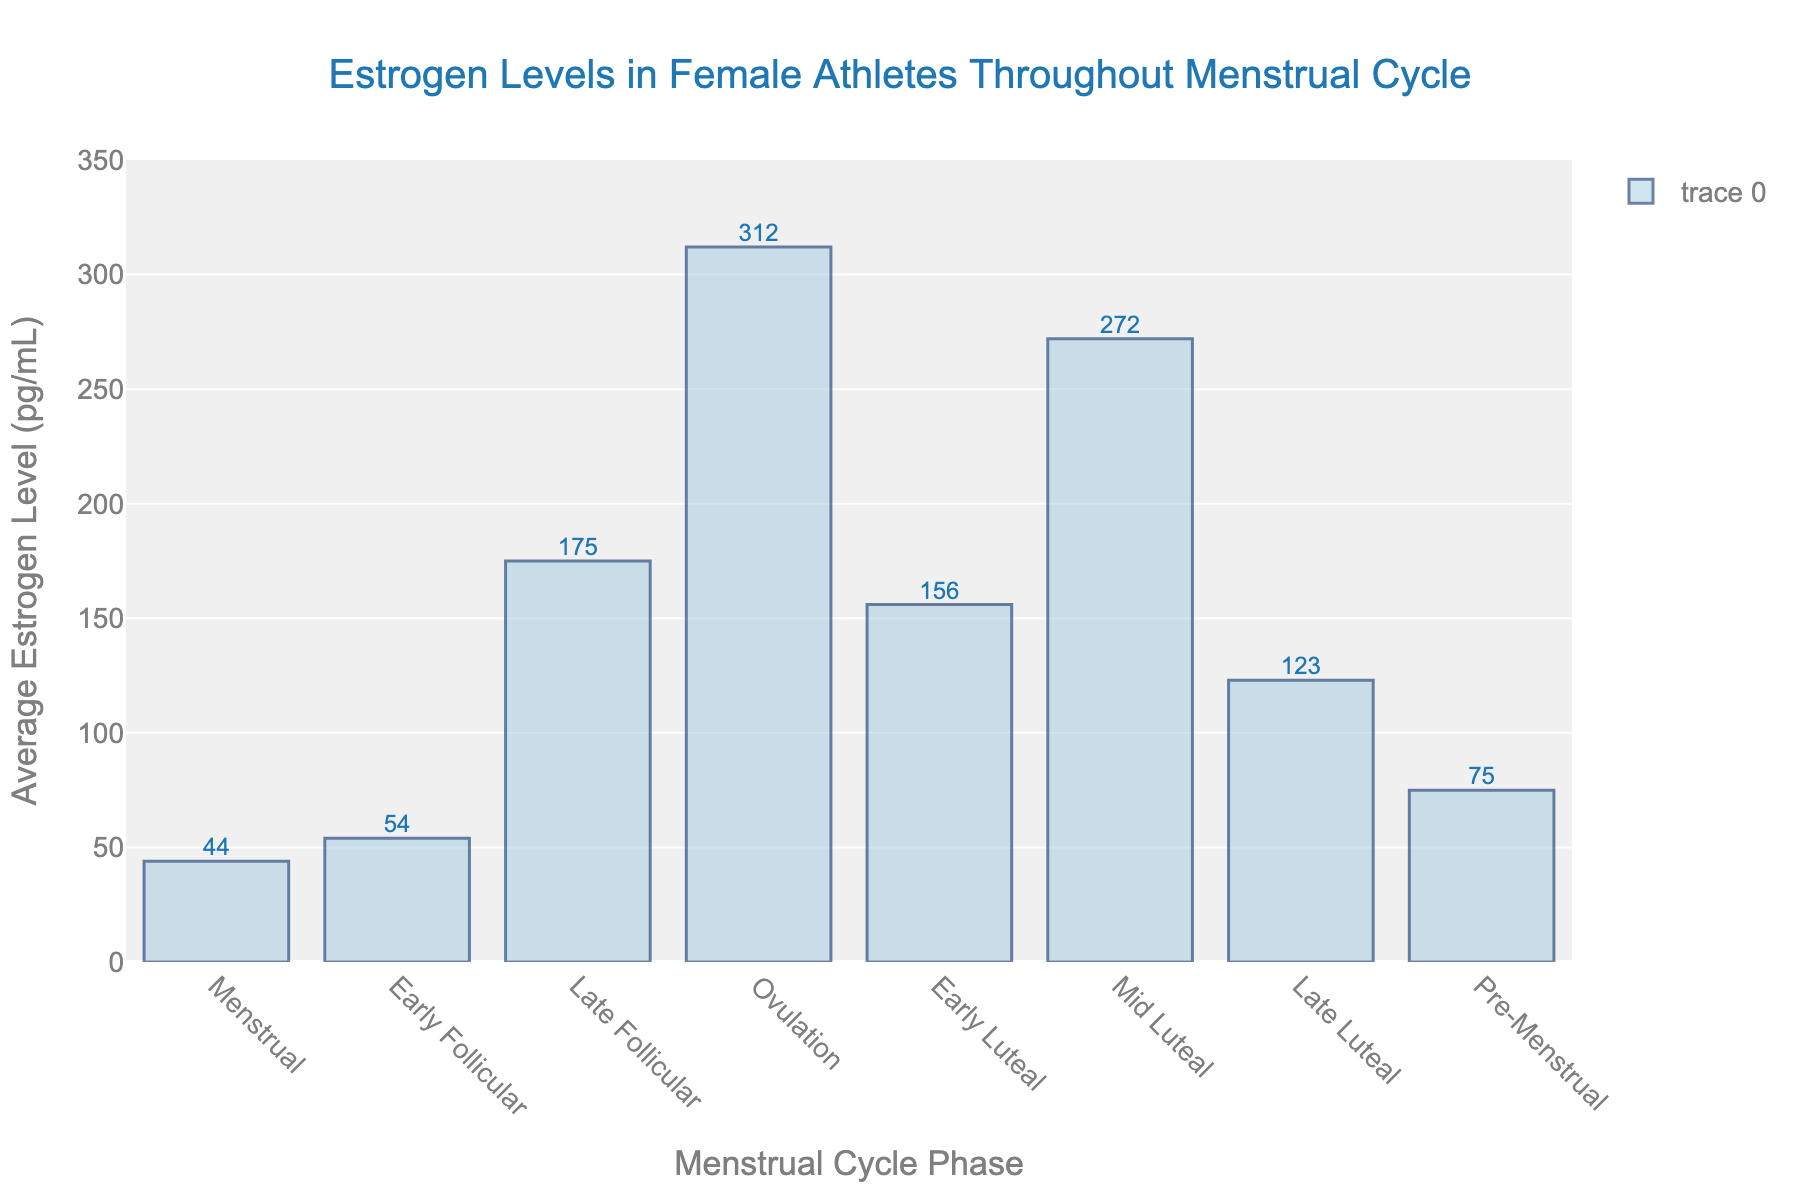Which phase has the highest average estrogen level? Identify the tallest bar in the chart, which represents the highest estrogen level. The bar for the Ovulation phase is the tallest.
Answer: Ovulation What is the difference in average estrogen levels between the Ovulation and Menstrual phases? Locate the estrogen levels of the Ovulation and Menstrual phases (312 pg/mL and 44 pg/mL, respectively). Subtract the Menstrual level from the Ovulation level: 312 - 44 = 268 pg/mL.
Answer: 268 pg/mL During which phase does the estrogen level first exceed 100 pg/mL? Examine each phase's estrogen level in ascending order. The Late Follicular phase shows an estrogen level of 175 pg/mL, which is the first value exceeding 100 pg/mL.
Answer: Late Follicular By how much does the estrogen level drop from its peak at Ovulation to the Early Luteal phase? Find the levels at Ovulation and Early Luteal phases (312 pg/mL and 156 pg/mL, respectively). Calculate the drop: 312 - 156 = 156 pg/mL.
Answer: 156 pg/mL What is the total average estrogen level across all phases? Sum the estrogen levels of all phases (44 + 54 + 175 + 312 + 156 + 272 + 123 + 75) = 1211 pg/mL.
Answer: 1211 pg/mL Which phase has the closest estrogen level to the average of the Menstrual and Pre-Menstrual phases? Calculate the average of the Menstrual and Pre-Menstrual phases: (44 + 75) / 2 = 59.5 pg/mL. Determine which phase's estrogen level is closest to 59.5 pg/mL (Early Follicular at 54 pg/mL).
Answer: Early Follicular How does the estrogen level change from the Mid Luteal to the Late Luteal phase? Compare the levels at Mid Luteal and Late Luteal phases (272 pg/mL and 123 pg/mL, respectively). Calculate the change: 123 - 272 = -149 pg/mL. The level decreases by 149 pg/mL.
Answer: Decreases by 149 pg/mL Which has a higher average estrogen level: the combined Follicular phases (Early & Late) or the combined Luteal phases (Early, Mid, & Late)? Calculate the combined average for Follicular (54 + 175) / 2 = 114.5 pg/mL and for Luteal ((156 + 272 + 123) / 3 = 183.67 pg/mL). Compare the two: 183.67 is higher than 114.5.
Answer: Combined Luteal phases How many phases have an estrogen level greater than 200 pg/mL? Identify the phases with estrogen levels above 200 pg/mL (312 for Ovulation and 272 for Mid Luteal).
Answer: 2 phases 